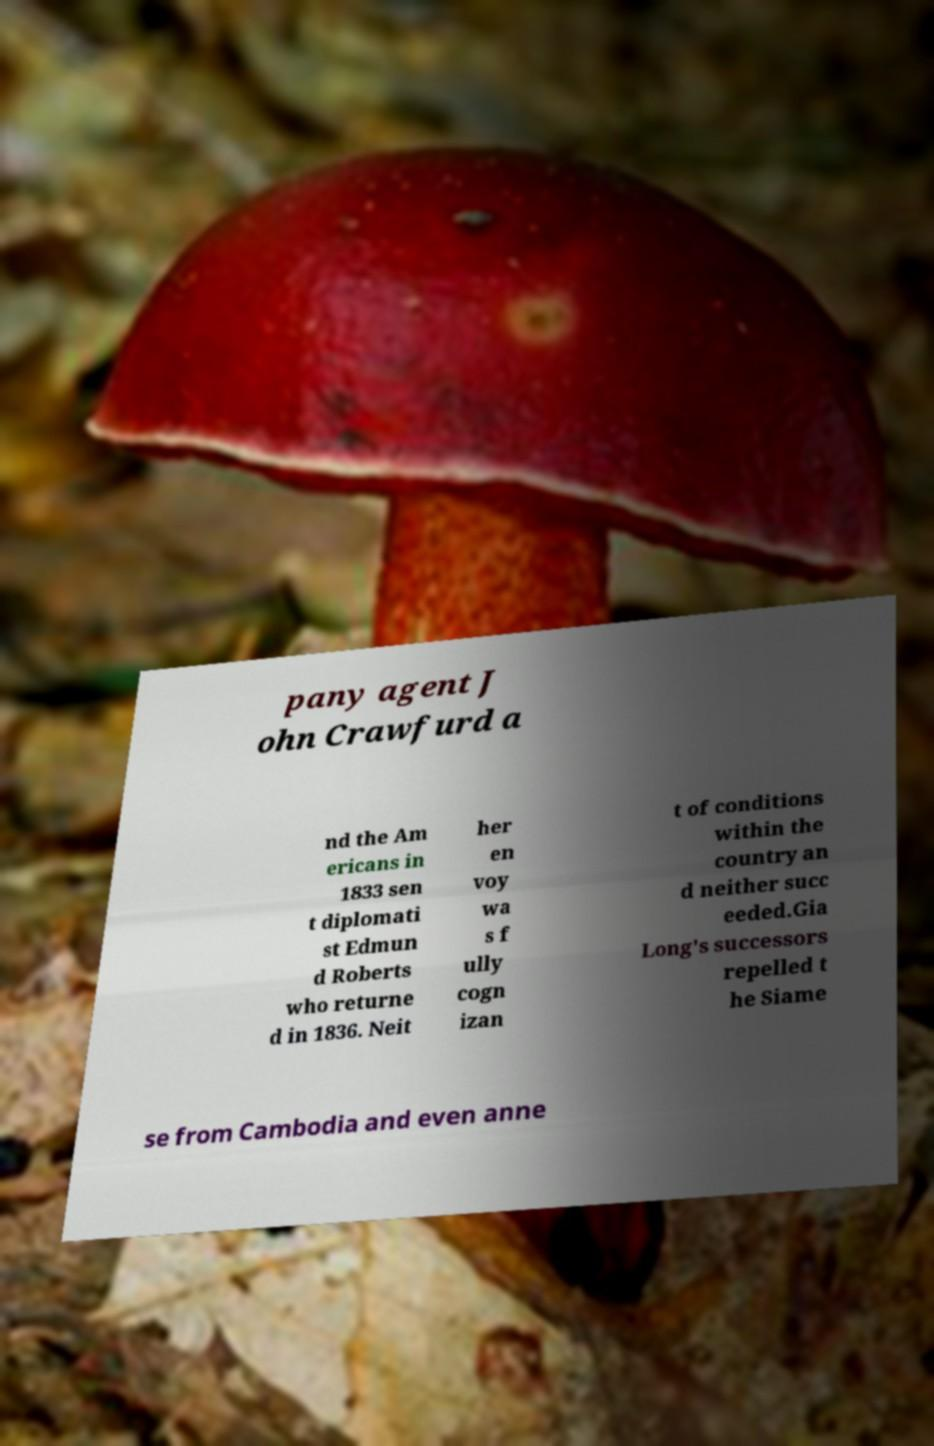For documentation purposes, I need the text within this image transcribed. Could you provide that? pany agent J ohn Crawfurd a nd the Am ericans in 1833 sen t diplomati st Edmun d Roberts who returne d in 1836. Neit her en voy wa s f ully cogn izan t of conditions within the country an d neither succ eeded.Gia Long's successors repelled t he Siame se from Cambodia and even anne 